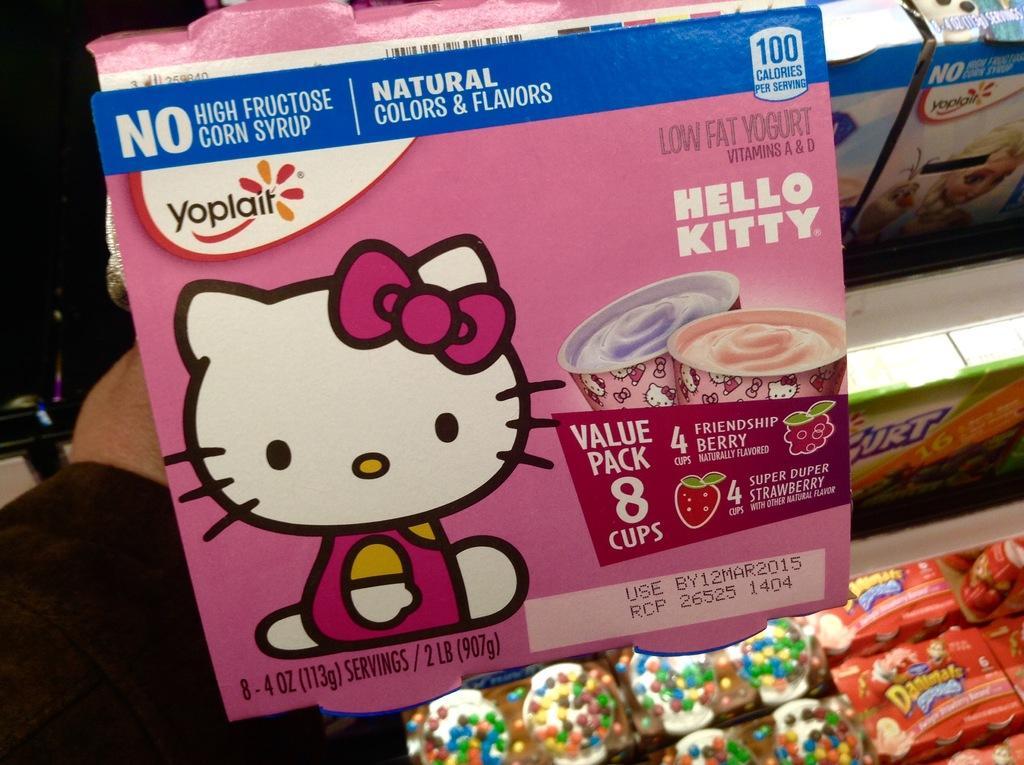Please provide a concise description of this image. In this picture I can see there is some food packed in the box, the person is holding the box and there are few chocolates arranged on the shelf. 